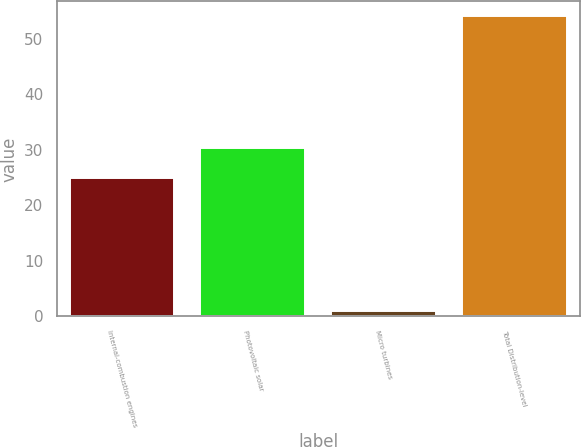<chart> <loc_0><loc_0><loc_500><loc_500><bar_chart><fcel>Internal-combustion engines<fcel>Photovoltaic solar<fcel>Micro turbines<fcel>Total Distribution-level<nl><fcel>25<fcel>30.3<fcel>1<fcel>54<nl></chart> 